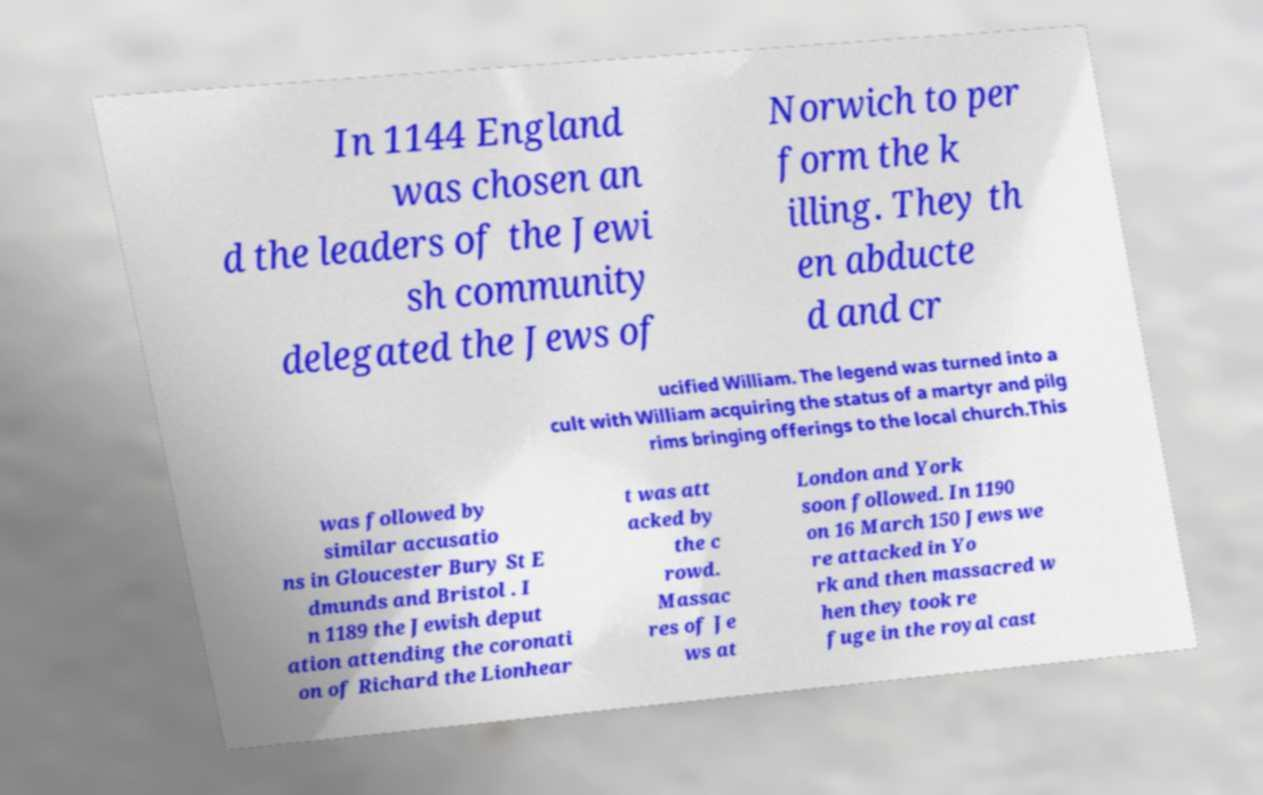Can you read and provide the text displayed in the image?This photo seems to have some interesting text. Can you extract and type it out for me? In 1144 England was chosen an d the leaders of the Jewi sh community delegated the Jews of Norwich to per form the k illing. They th en abducte d and cr ucified William. The legend was turned into a cult with William acquiring the status of a martyr and pilg rims bringing offerings to the local church.This was followed by similar accusatio ns in Gloucester Bury St E dmunds and Bristol . I n 1189 the Jewish deput ation attending the coronati on of Richard the Lionhear t was att acked by the c rowd. Massac res of Je ws at London and York soon followed. In 1190 on 16 March 150 Jews we re attacked in Yo rk and then massacred w hen they took re fuge in the royal cast 